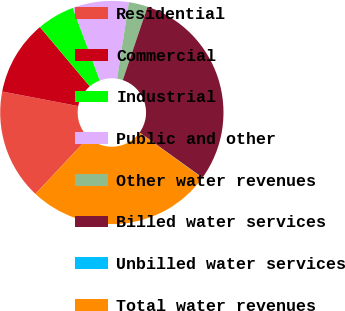Convert chart to OTSL. <chart><loc_0><loc_0><loc_500><loc_500><pie_chart><fcel>Residential<fcel>Commercial<fcel>Industrial<fcel>Public and other<fcel>Other water revenues<fcel>Billed water services<fcel>Unbilled water services<fcel>Total water revenues<nl><fcel>16.02%<fcel>10.85%<fcel>5.44%<fcel>8.14%<fcel>2.74%<fcel>29.74%<fcel>0.03%<fcel>27.04%<nl></chart> 